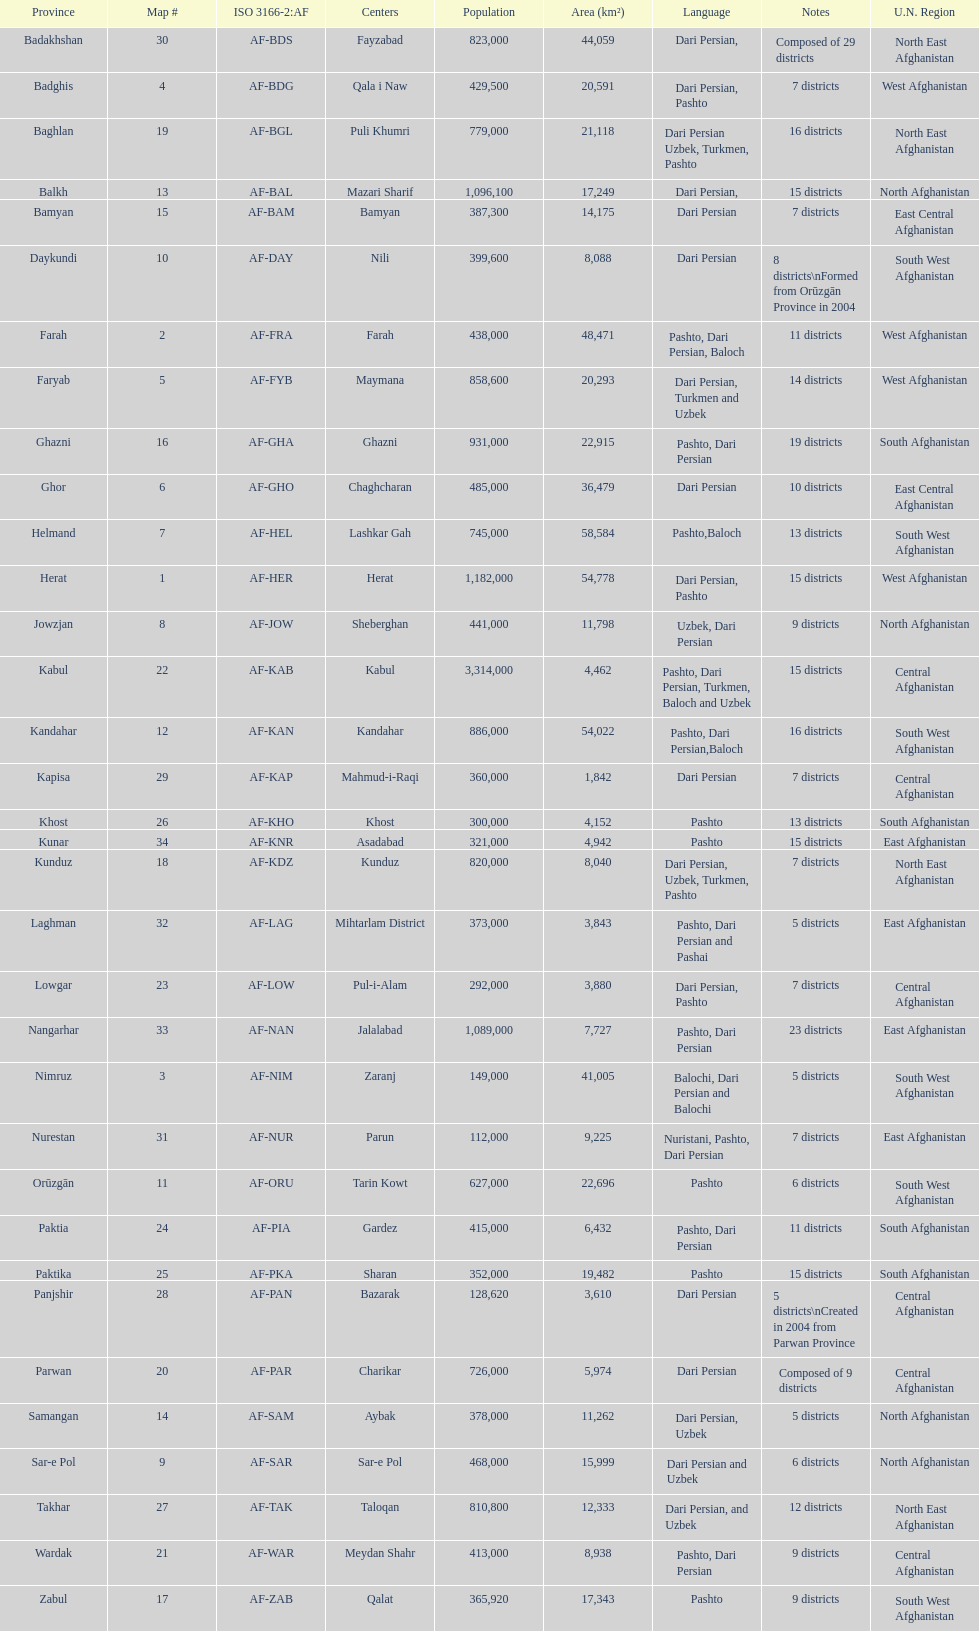Herat's population is 1,182,000, can you identify their languages? Dari Persian, Pashto. 